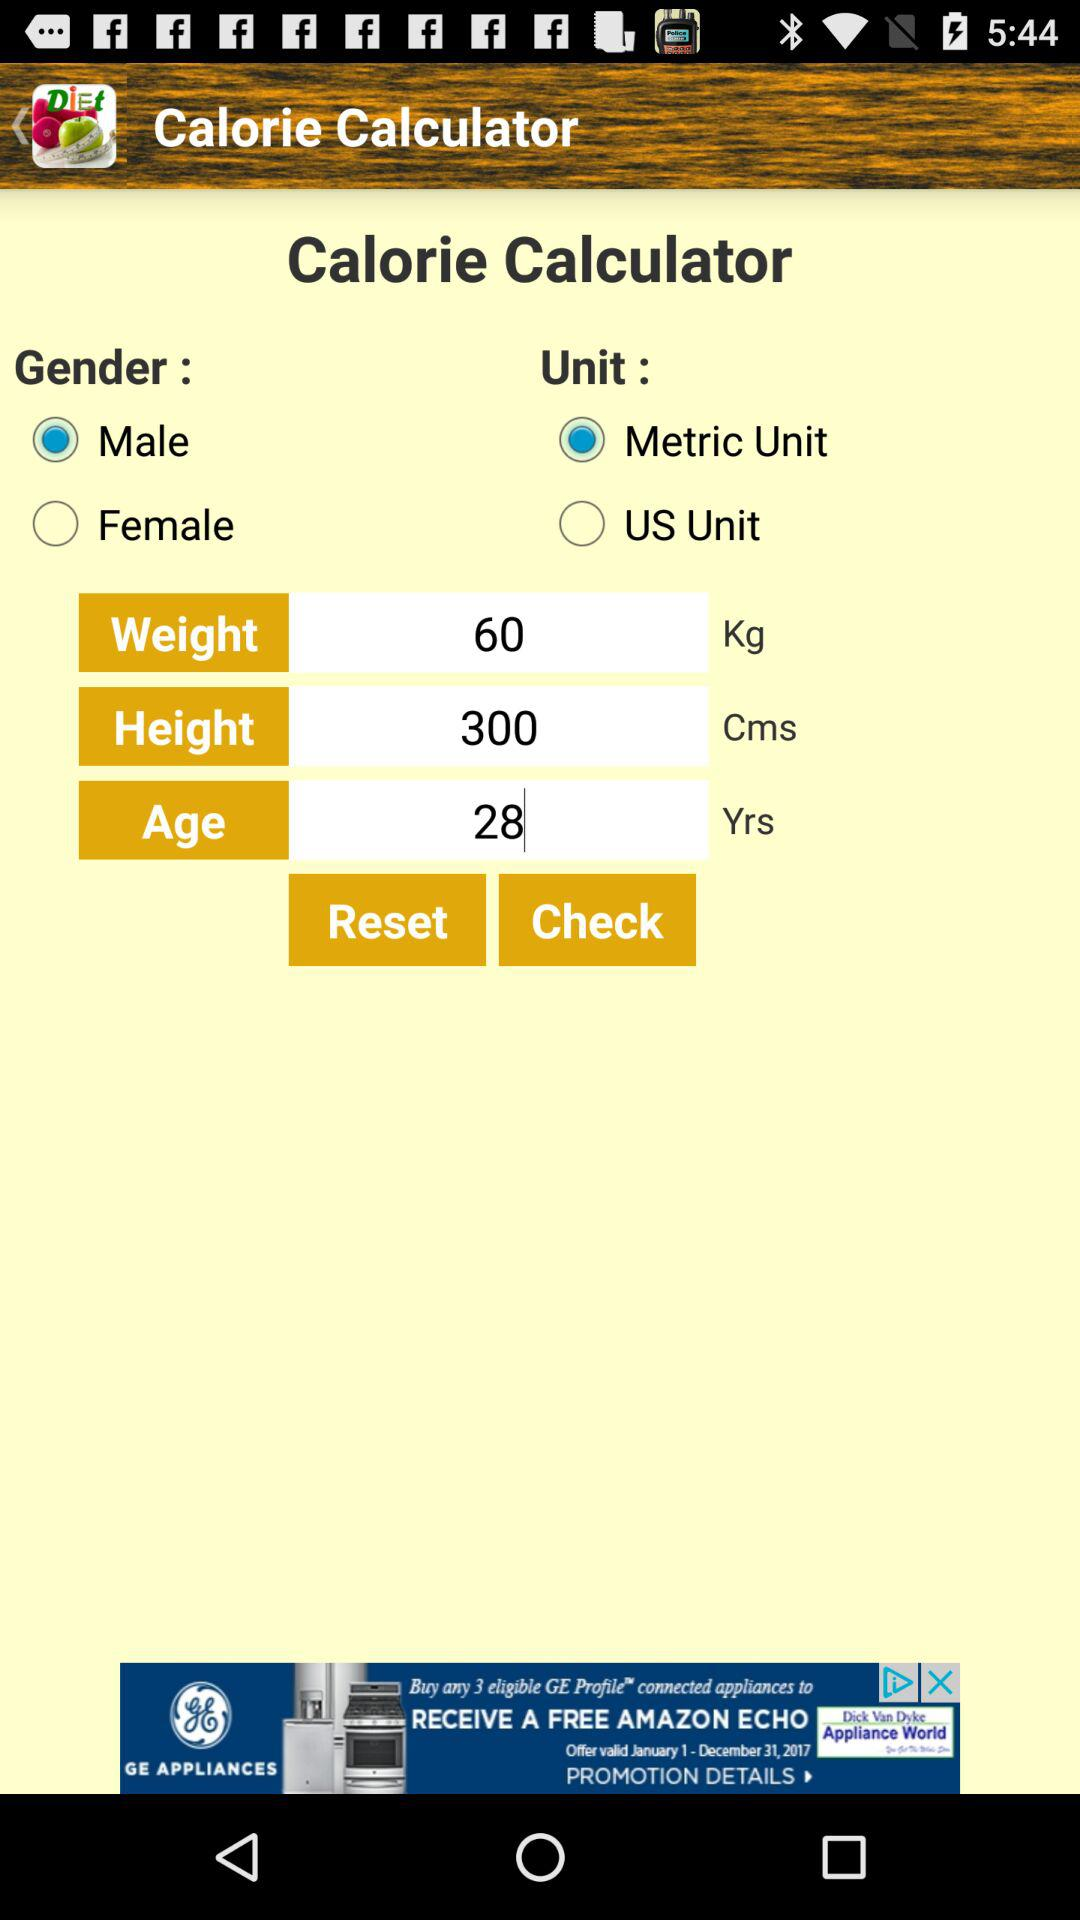What is the given weight? The given weight is 60 kg. 